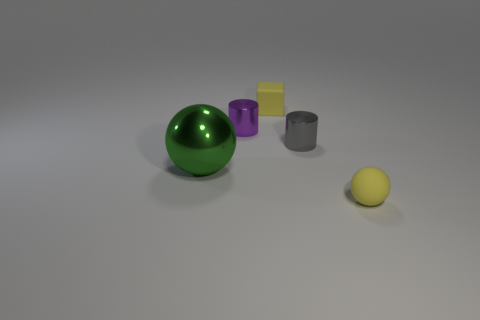Add 3 large metal things. How many objects exist? 8 Subtract all blocks. How many objects are left? 4 Subtract all blocks. Subtract all small yellow cubes. How many objects are left? 3 Add 5 big metallic balls. How many big metallic balls are left? 6 Add 3 big yellow spheres. How many big yellow spheres exist? 3 Subtract 0 gray balls. How many objects are left? 5 